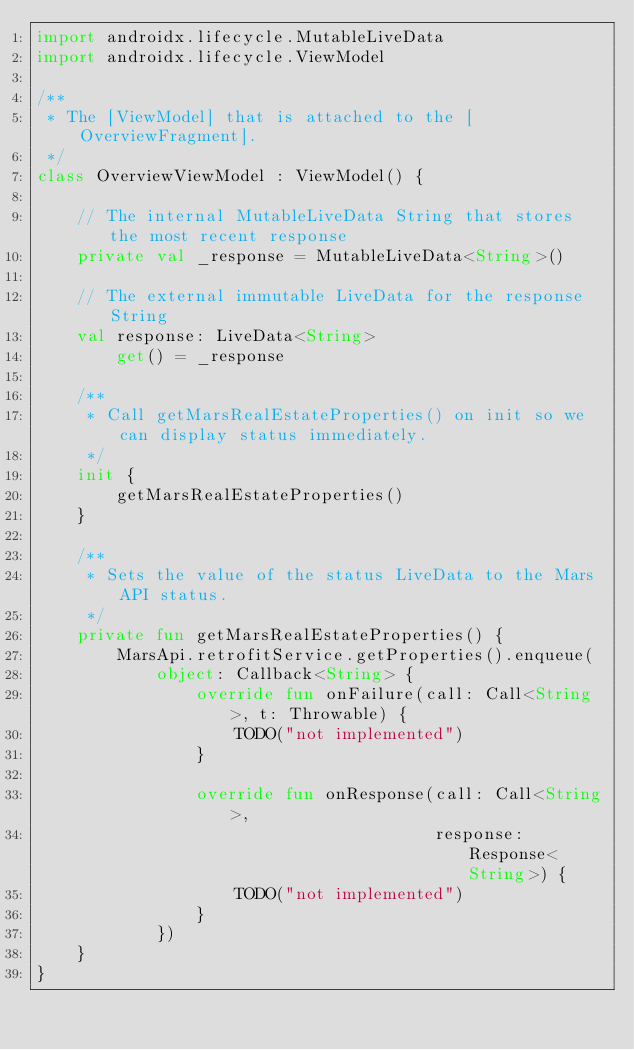Convert code to text. <code><loc_0><loc_0><loc_500><loc_500><_Kotlin_>import androidx.lifecycle.MutableLiveData
import androidx.lifecycle.ViewModel

/**
 * The [ViewModel] that is attached to the [OverviewFragment].
 */
class OverviewViewModel : ViewModel() {

    // The internal MutableLiveData String that stores the most recent response
    private val _response = MutableLiveData<String>()

    // The external immutable LiveData for the response String
    val response: LiveData<String>
        get() = _response

    /**
     * Call getMarsRealEstateProperties() on init so we can display status immediately.
     */
    init {
        getMarsRealEstateProperties()
    }

    /**
     * Sets the value of the status LiveData to the Mars API status.
     */
    private fun getMarsRealEstateProperties() {
        MarsApi.retrofitService.getProperties().enqueue(
            object: Callback<String> {
                override fun onFailure(call: Call<String>, t: Throwable) {
                    TODO("not implemented")
                }

                override fun onResponse(call: Call<String>,
                                        response: Response<String>) {
                    TODO("not implemented")
                }
            })
    }
}
</code> 